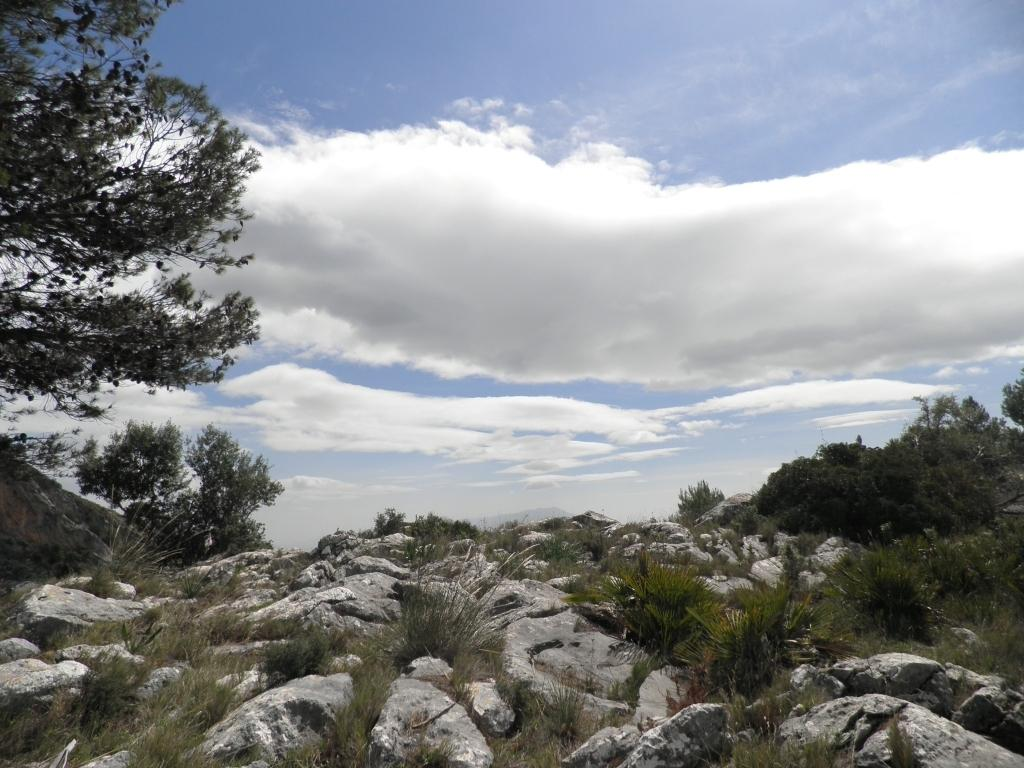What type of natural elements can be seen in the image? There are rocks in the image. What other natural elements are present near the rocks? There are plants beside the rocks and trees on either side of the rocks. What is visible in the background of the image? The sky is visible in the image and appears to be cloudy. What theory is being discussed by the women in the image? There are no women present in the image, and therefore no discussion or theory can be observed. How much debt is represented by the rocks in the image? The rocks in the image do not represent any form of debt; they are simply natural elements. 